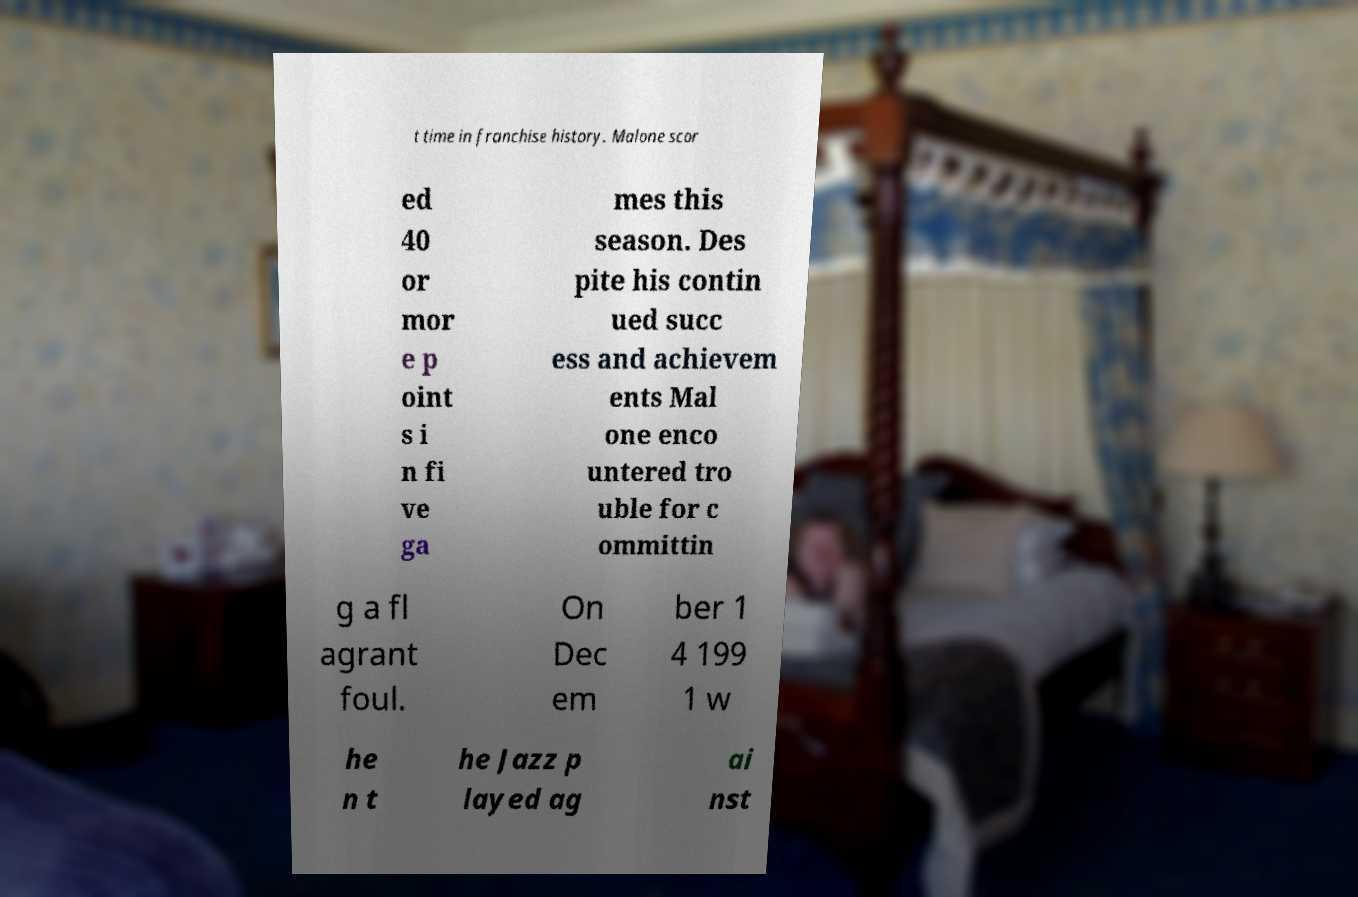Can you read and provide the text displayed in the image?This photo seems to have some interesting text. Can you extract and type it out for me? t time in franchise history. Malone scor ed 40 or mor e p oint s i n fi ve ga mes this season. Des pite his contin ued succ ess and achievem ents Mal one enco untered tro uble for c ommittin g a fl agrant foul. On Dec em ber 1 4 199 1 w he n t he Jazz p layed ag ai nst 